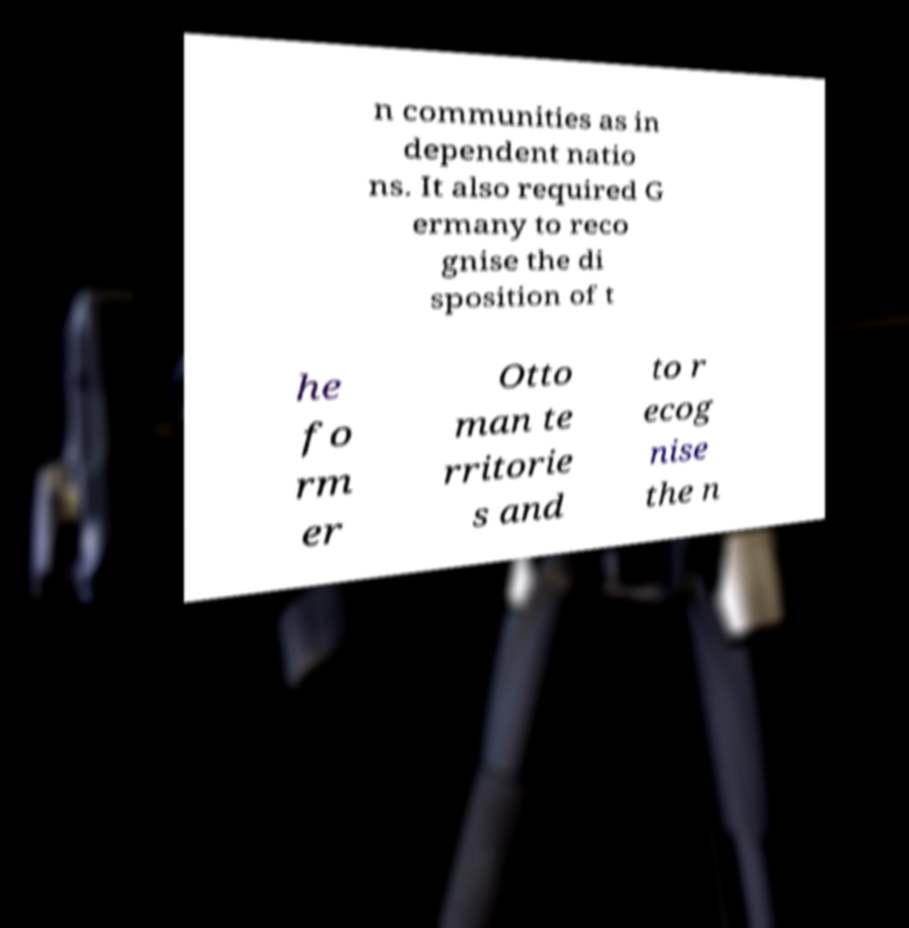Please read and relay the text visible in this image. What does it say? n communities as in dependent natio ns. It also required G ermany to reco gnise the di sposition of t he fo rm er Otto man te rritorie s and to r ecog nise the n 